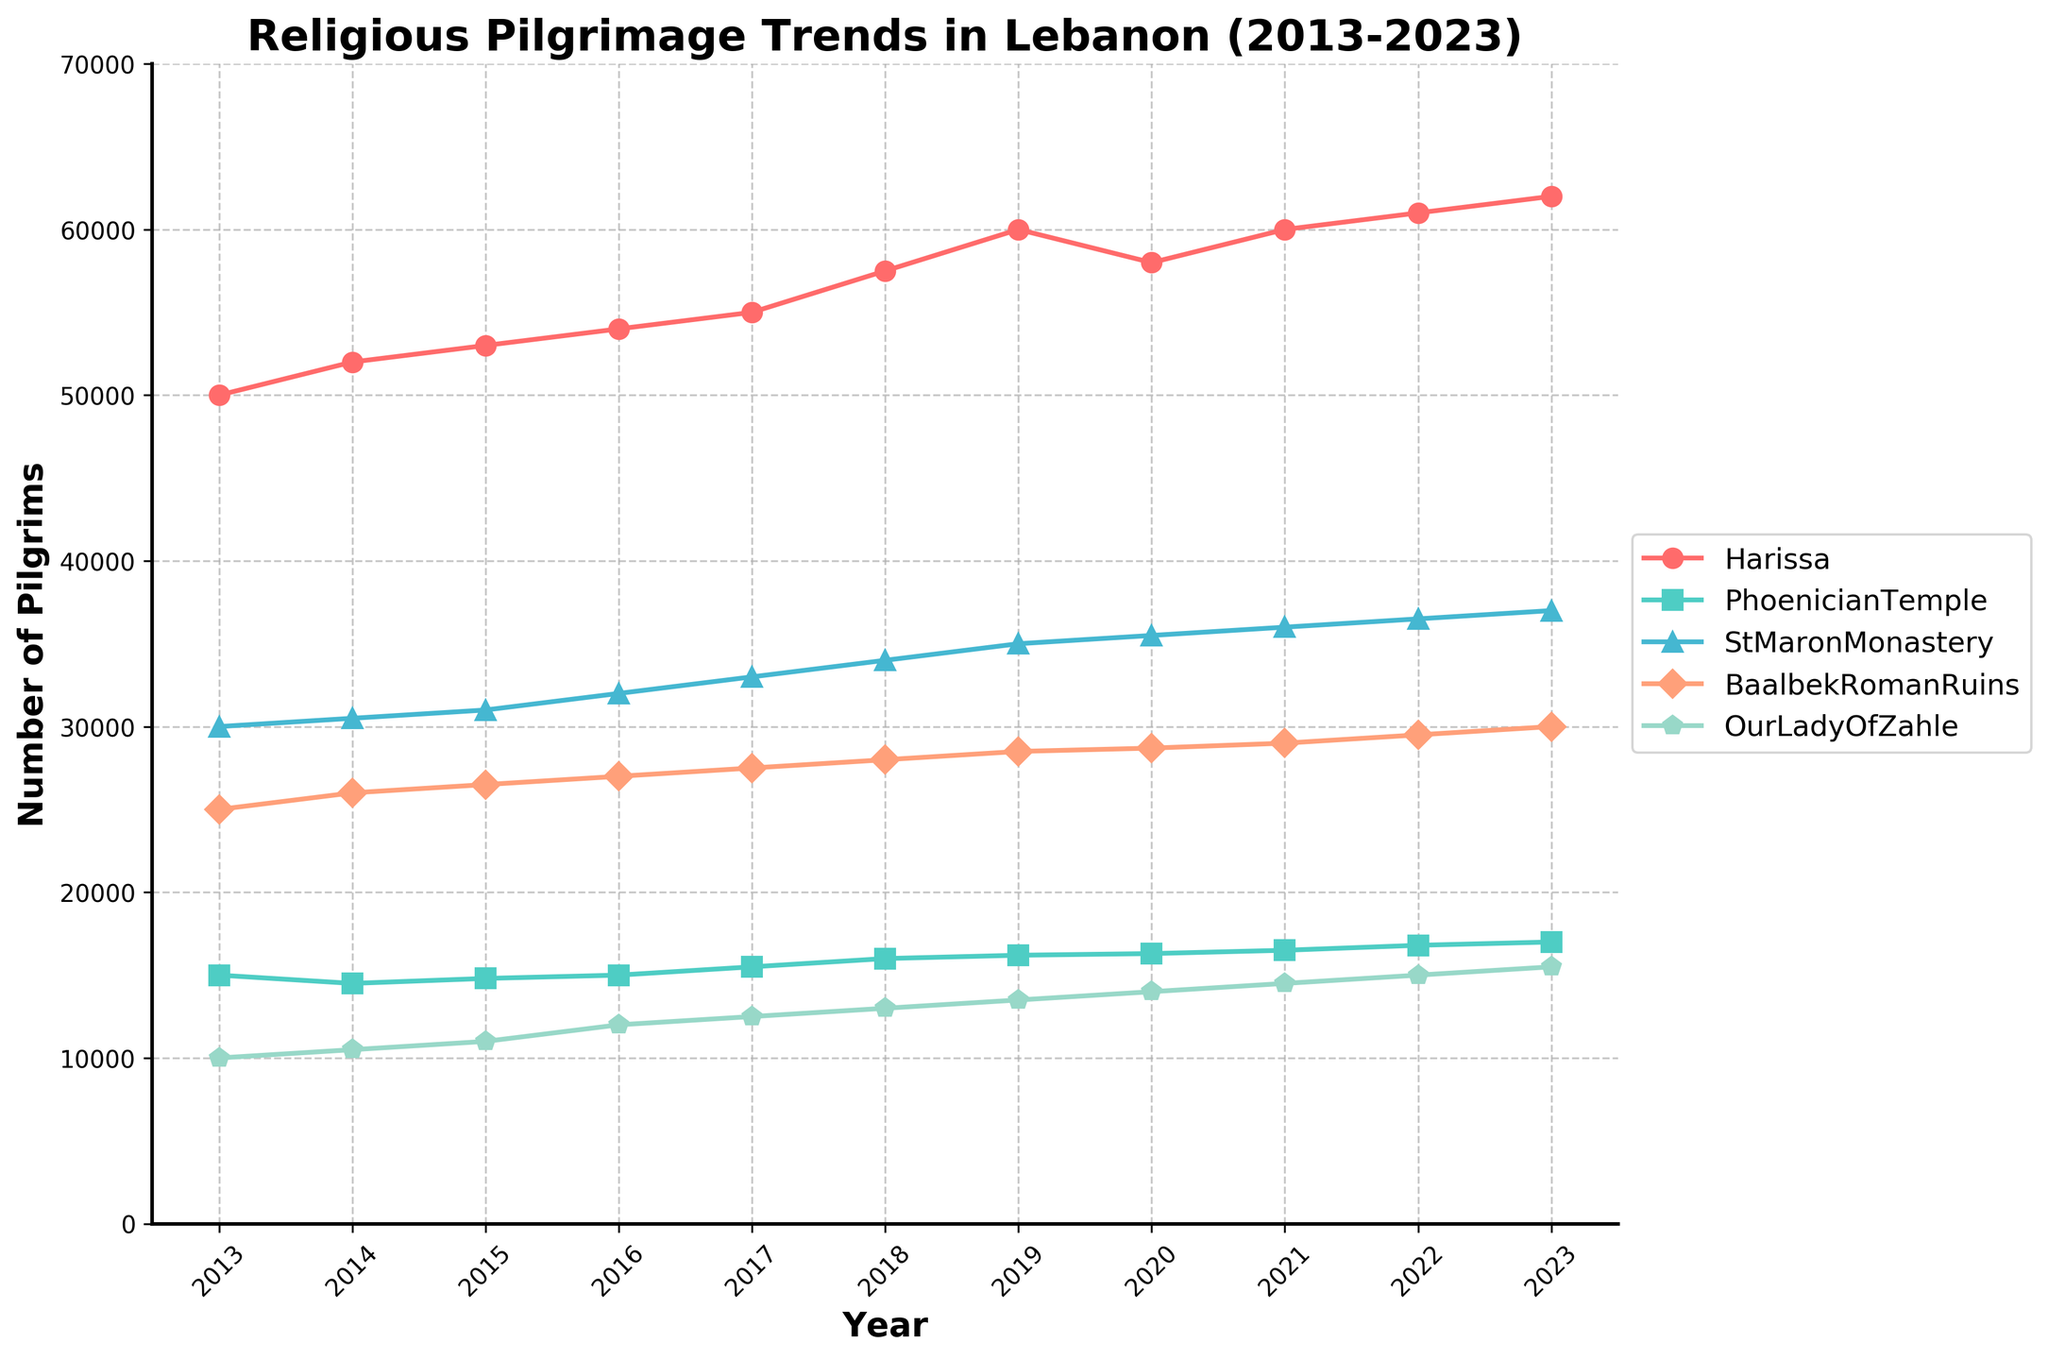What is the title of the figure? The title is located at the top of the figure and summarizes the main focus of the data. In this case, it clearly states the topic of the figure.
Answer: Religious Pilgrimage Trends in Lebanon (2013-2023) How many locations are tracked in the figure? The legend in the figure lists all the tracked locations. By counting the entries in the legend, we see there are five locations tracked.
Answer: Five Which location had the highest number of pilgrims in 2013? By looking at the starting points of each line on the plot for the year 2013, we can identify which line starts at the highest value on the y-axis.
Answer: Harissa Did any of the locations see a decline in pilgrims during the period from 2019 to 2020? Compare the y-values of each location between 2019 and 2020. The line that shows a decrease between these years indicates a decline.
Answer: Harissa What is the approximate number of pilgrims for Our Lady Of Zahle in 2023? Locate the end of the line for Our Lady Of Zahle at the 2023 mark on the x-axis and read the corresponding y-value.
Answer: 15,500 Which location shows the most consistent increase in pilgrims over the decade? Observing the lines for each location, the line that steadily inclines without major dips indicates the most consistent increase.
Answer: St Maron Monastery What is the average number of pilgrims visiting Baalbek Roman Ruins over the entire decade? Sum the number of pilgrims visiting Baalbek each year and then divide by the number of years (11).
Answer: (25000+26000+26500+27000+27500+28000+28500+28700+29000+29500+30000) / 11 = 27,000 Which year saw the highest number of pilgrims visiting Harissa? Identify the peak point on the Harissa line and note the corresponding year on the x-axis.
Answer: 2023 How many more pilgrims visited Harissa than the Phoenician Temple in 2016? Subtract the number of pilgrims at the Phoenician Temple from those at Harissa for the year 2016.
Answer: 54,000 - 15,000 = 39,000 Which two locations had almost the same number of pilgrims in 2014? Compare the y-values for all locations in 2014 and identify any that are close to each other.
Answer: Harissa and St Maron Monastery 